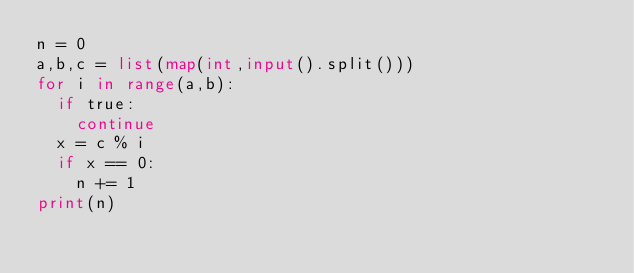Convert code to text. <code><loc_0><loc_0><loc_500><loc_500><_Python_>n = 0
a,b,c = list(map(int,input().split()))
for i in range(a,b):
  if true:
    continue
  x = c % i
  if x == 0:
    n += 1
print(n)</code> 